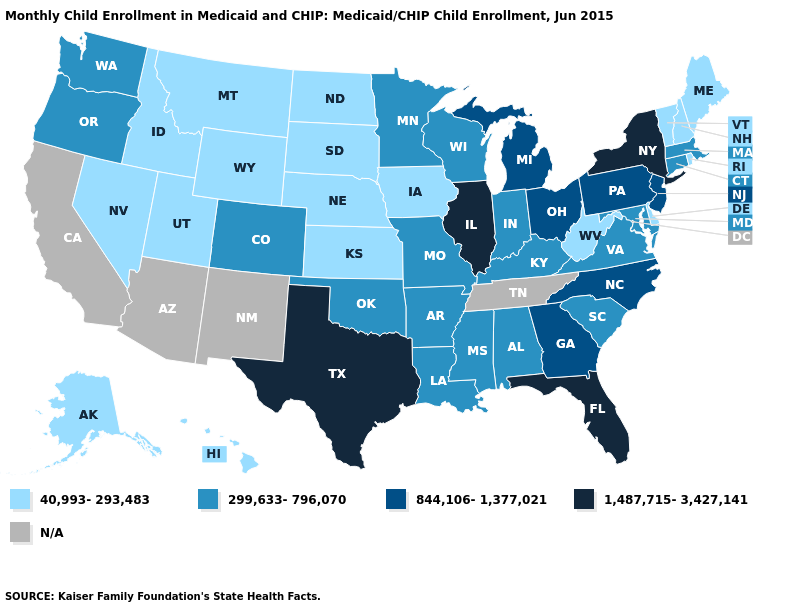Is the legend a continuous bar?
Be succinct. No. Which states have the lowest value in the Northeast?
Be succinct. Maine, New Hampshire, Rhode Island, Vermont. What is the value of Missouri?
Concise answer only. 299,633-796,070. What is the value of Idaho?
Keep it brief. 40,993-293,483. Among the states that border Colorado , which have the lowest value?
Concise answer only. Kansas, Nebraska, Utah, Wyoming. Which states have the highest value in the USA?
Keep it brief. Florida, Illinois, New York, Texas. Among the states that border Illinois , does Iowa have the lowest value?
Quick response, please. Yes. Does New Jersey have the highest value in the Northeast?
Keep it brief. No. What is the lowest value in the MidWest?
Keep it brief. 40,993-293,483. Name the states that have a value in the range N/A?
Keep it brief. Arizona, California, New Mexico, Tennessee. What is the lowest value in the USA?
Give a very brief answer. 40,993-293,483. Name the states that have a value in the range 299,633-796,070?
Quick response, please. Alabama, Arkansas, Colorado, Connecticut, Indiana, Kentucky, Louisiana, Maryland, Massachusetts, Minnesota, Mississippi, Missouri, Oklahoma, Oregon, South Carolina, Virginia, Washington, Wisconsin. Name the states that have a value in the range 844,106-1,377,021?
Be succinct. Georgia, Michigan, New Jersey, North Carolina, Ohio, Pennsylvania. Name the states that have a value in the range 40,993-293,483?
Be succinct. Alaska, Delaware, Hawaii, Idaho, Iowa, Kansas, Maine, Montana, Nebraska, Nevada, New Hampshire, North Dakota, Rhode Island, South Dakota, Utah, Vermont, West Virginia, Wyoming. 